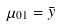<formula> <loc_0><loc_0><loc_500><loc_500>\mu _ { 0 1 } = \bar { y }</formula> 